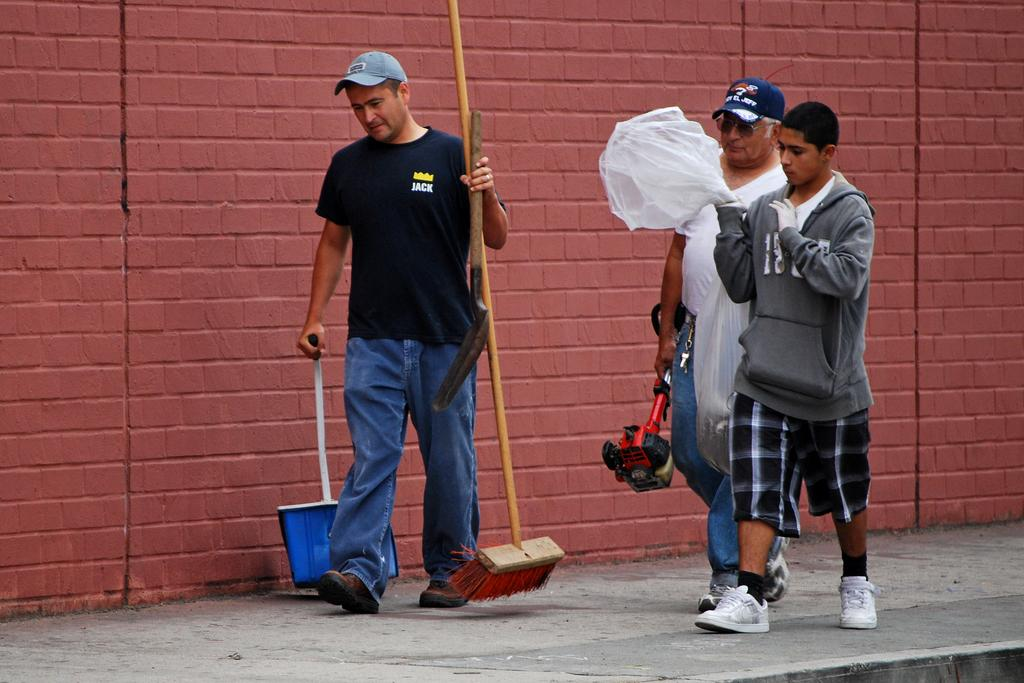How many people are in the image? There are three men in the image. What are the men doing in the image? The men are walking on a walkway. What are the men holding in the image? The men are holding objects. What can be seen in the background of the image? There is a wall in the background of the image. How many jellyfish can be seen swimming in the image? There are no jellyfish present in the image; it features three men walking on a walkway. What type of underwear is the fifth person wearing in the image? There is no fifth person in the image, and therefore no underwear to describe. 